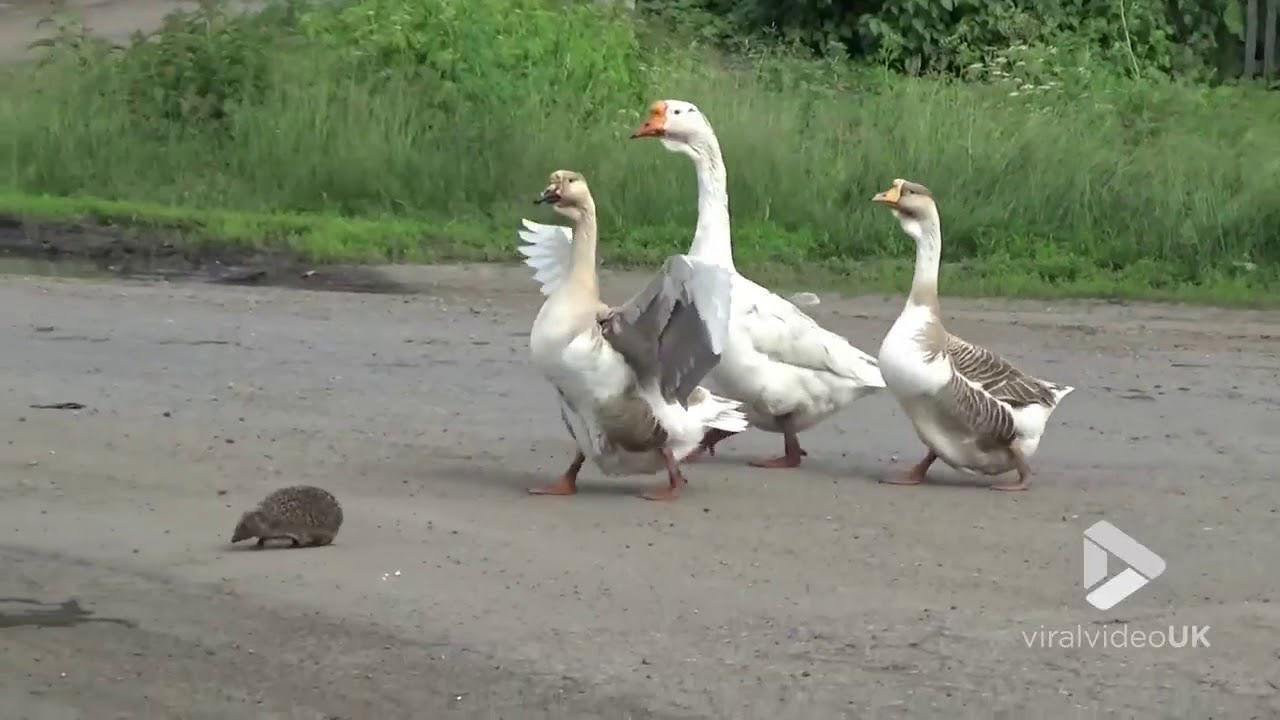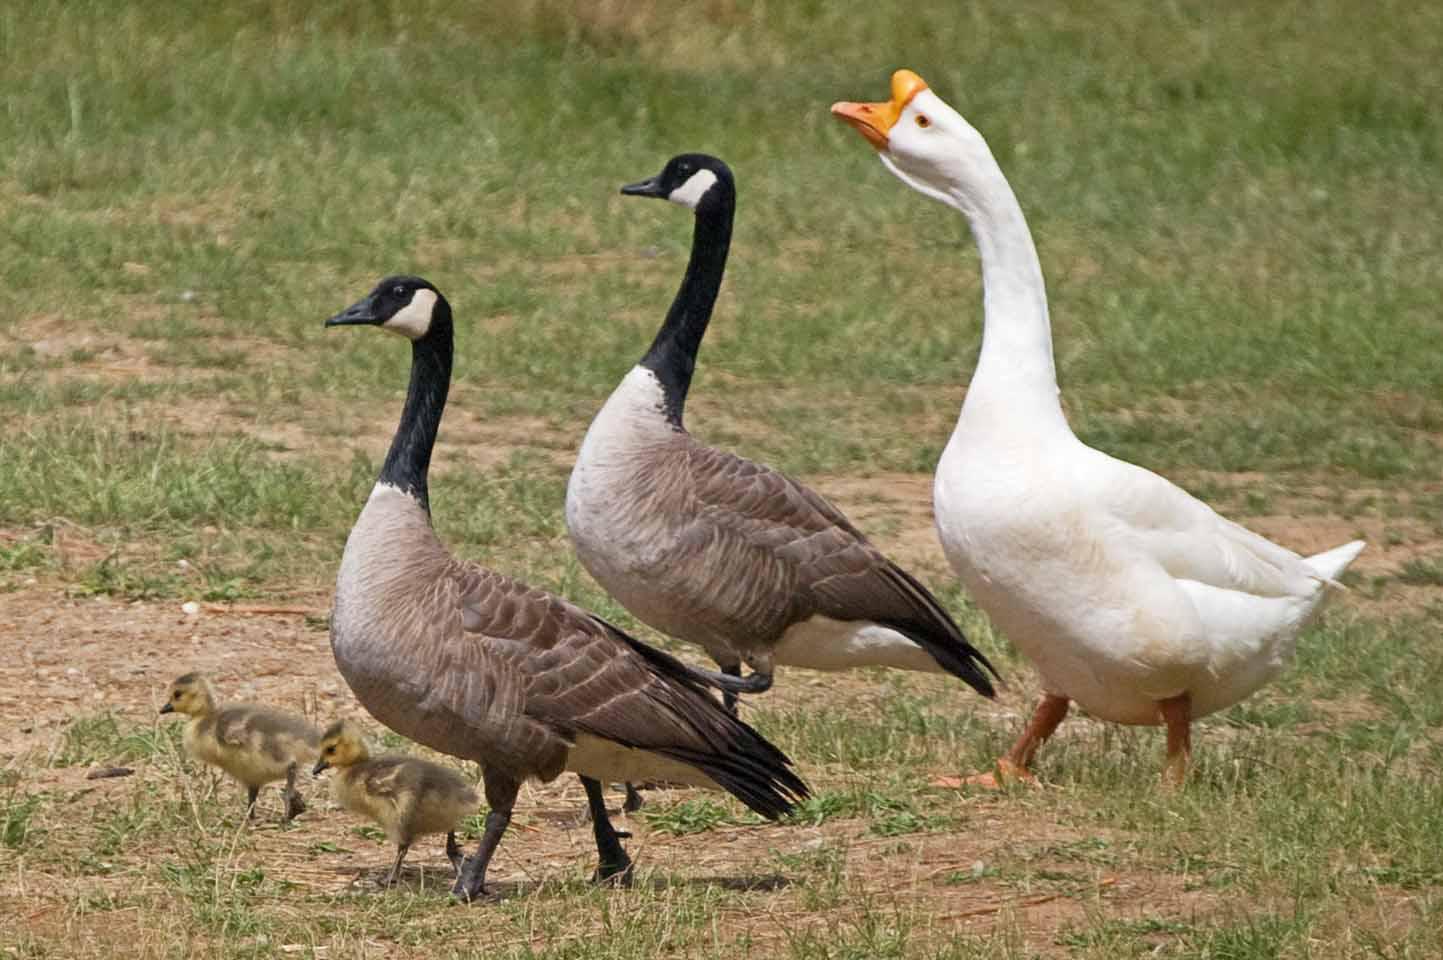The first image is the image on the left, the second image is the image on the right. Assess this claim about the two images: "In the left image, three geese with orange beaks are floating on water". Correct or not? Answer yes or no. No. The first image is the image on the left, the second image is the image on the right. Assess this claim about the two images: "Three birds float on a pool of water and none of them face leftward, in one image.". Correct or not? Answer yes or no. No. 